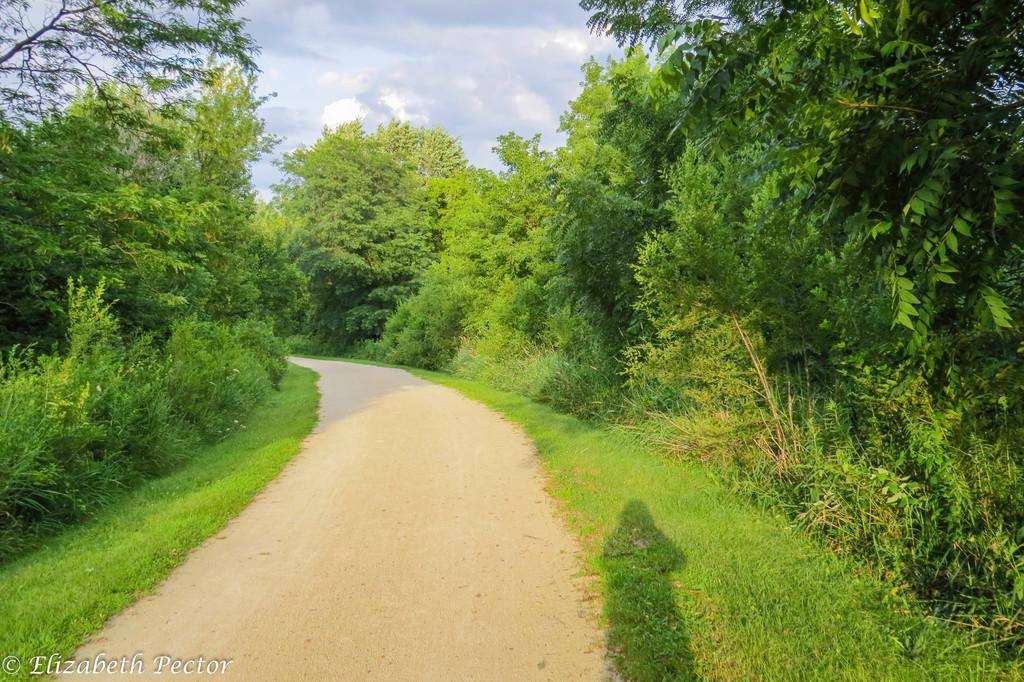What type of vegetation can be seen in the image? There is grass in the image. What other natural elements are present in the image? There are trees in the image. What can be seen in the sky in the image? There are white clouds visible in the image. Where can the receipt for the food be found in the image? There is no food, receipt, or any indication of a transaction in the image. 